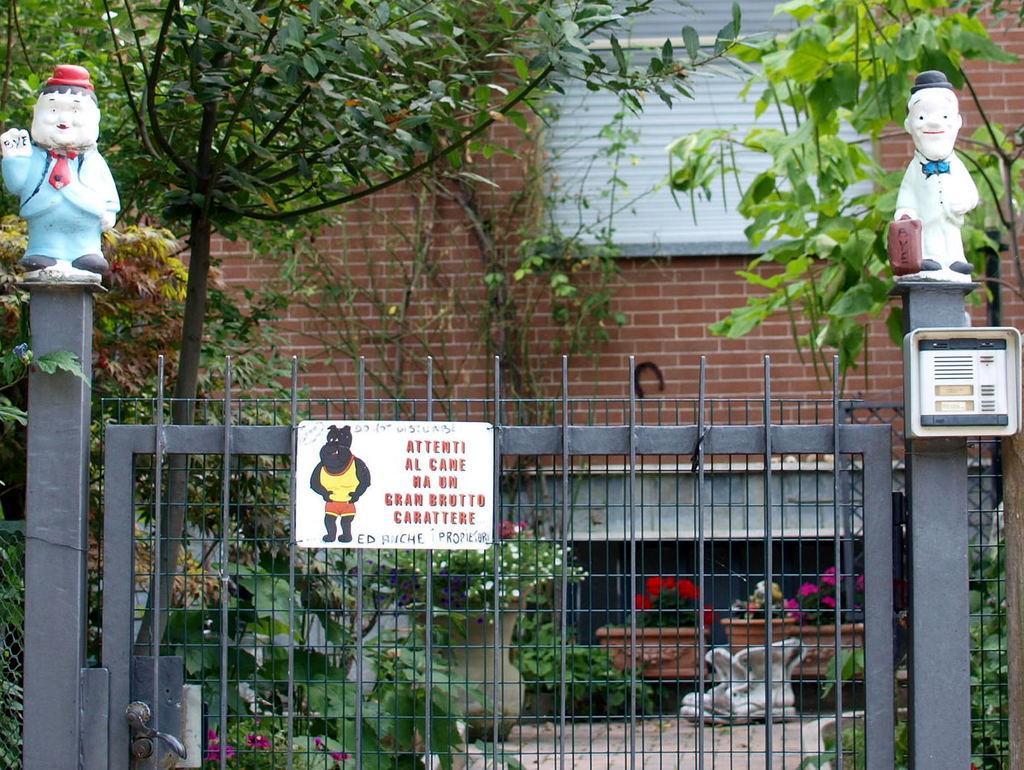In one or two sentences, can you explain what this image depicts? In this image we can see a board on the gate and there are two sculptures on the poles and an object on the pole. In the background we can see plants with flowers, trees, building and a window. 